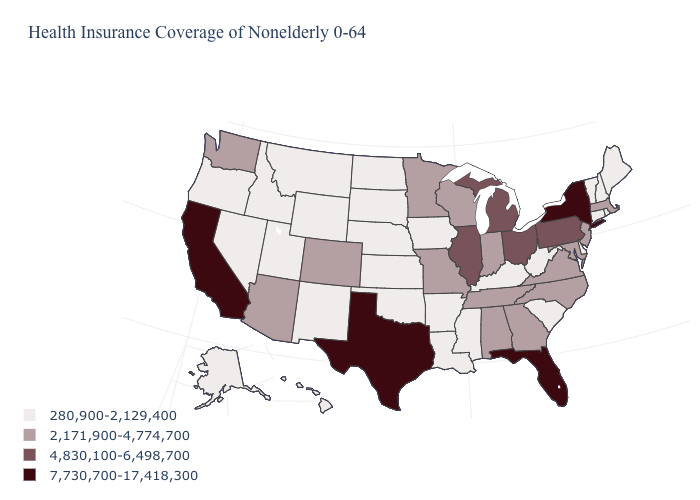Name the states that have a value in the range 2,171,900-4,774,700?
Concise answer only. Alabama, Arizona, Colorado, Georgia, Indiana, Maryland, Massachusetts, Minnesota, Missouri, New Jersey, North Carolina, Tennessee, Virginia, Washington, Wisconsin. Name the states that have a value in the range 280,900-2,129,400?
Write a very short answer. Alaska, Arkansas, Connecticut, Delaware, Hawaii, Idaho, Iowa, Kansas, Kentucky, Louisiana, Maine, Mississippi, Montana, Nebraska, Nevada, New Hampshire, New Mexico, North Dakota, Oklahoma, Oregon, Rhode Island, South Carolina, South Dakota, Utah, Vermont, West Virginia, Wyoming. Does the first symbol in the legend represent the smallest category?
Concise answer only. Yes. What is the highest value in the West ?
Concise answer only. 7,730,700-17,418,300. What is the value of Indiana?
Write a very short answer. 2,171,900-4,774,700. Among the states that border Oklahoma , which have the highest value?
Quick response, please. Texas. What is the value of California?
Quick response, please. 7,730,700-17,418,300. Does South Dakota have the highest value in the USA?
Short answer required. No. Among the states that border Ohio , which have the highest value?
Answer briefly. Michigan, Pennsylvania. Among the states that border Virginia , which have the lowest value?
Concise answer only. Kentucky, West Virginia. Does New York have the highest value in the USA?
Write a very short answer. Yes. Among the states that border Colorado , does Arizona have the highest value?
Concise answer only. Yes. Among the states that border Connecticut , which have the lowest value?
Keep it brief. Rhode Island. What is the value of New Mexico?
Concise answer only. 280,900-2,129,400. Name the states that have a value in the range 2,171,900-4,774,700?
Concise answer only. Alabama, Arizona, Colorado, Georgia, Indiana, Maryland, Massachusetts, Minnesota, Missouri, New Jersey, North Carolina, Tennessee, Virginia, Washington, Wisconsin. 